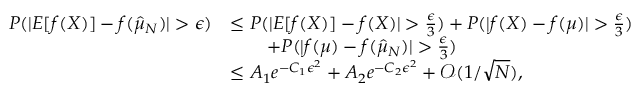Convert formula to latex. <formula><loc_0><loc_0><loc_500><loc_500>\begin{array} { r l } { P ( | E [ f ( X ) ] - f ( \hat { \mu } _ { N } ) | > \epsilon ) } & { \leq P ( | E [ f ( X ) ] - f ( X ) | > \frac { \epsilon } { 3 } ) + P ( | f ( X ) - f ( \mu ) | > \frac { \epsilon } { 3 } ) } \\ & { \quad + P ( | f ( \mu ) - f ( \hat { \mu } _ { N } ) | > \frac { \epsilon } { 3 } ) } \\ & { \leq A _ { 1 } e ^ { - C _ { 1 } \epsilon ^ { 2 } } + A _ { 2 } e ^ { - C _ { 2 } \epsilon ^ { 2 } } + \mathcal { O } ( 1 / \sqrt { N } ) , } \end{array}</formula> 